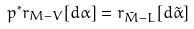<formula> <loc_0><loc_0><loc_500><loc_500>p ^ { * } r _ { M - V } [ d \alpha ] = r _ { \tilde { M } - L } [ d \tilde { \alpha } ]</formula> 